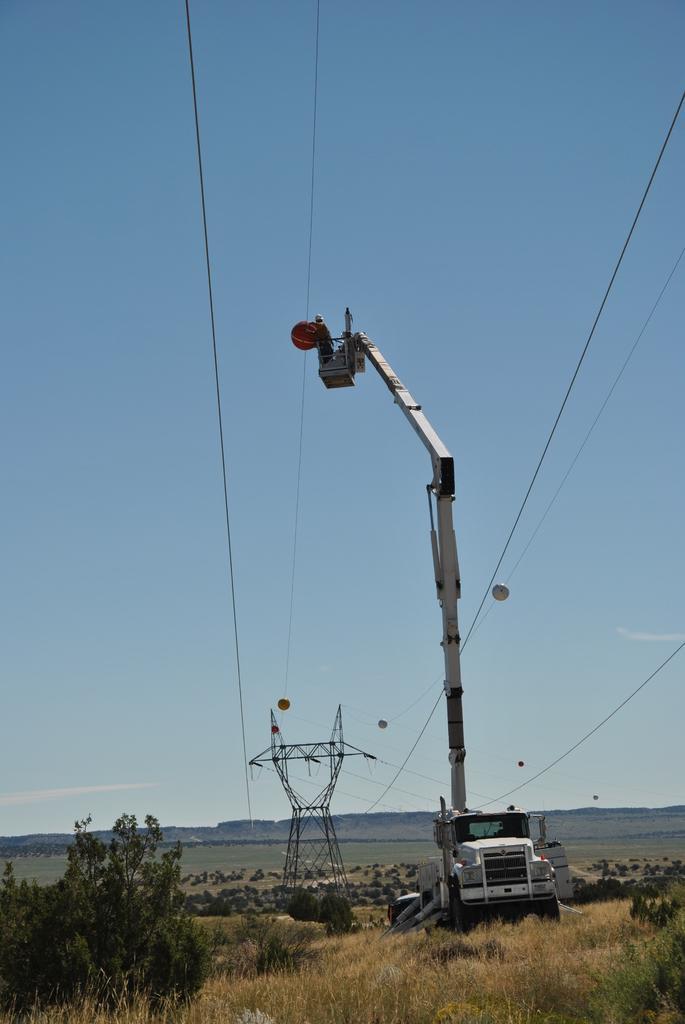Please provide a concise description of this image. In this image we can see a person standing in a cage of a crane placed on the ground, holding a ball in his hand. In the background, we can see a group of trees, a metal tower with cables, mountains and the sky. In the foreground we can see the grass. 